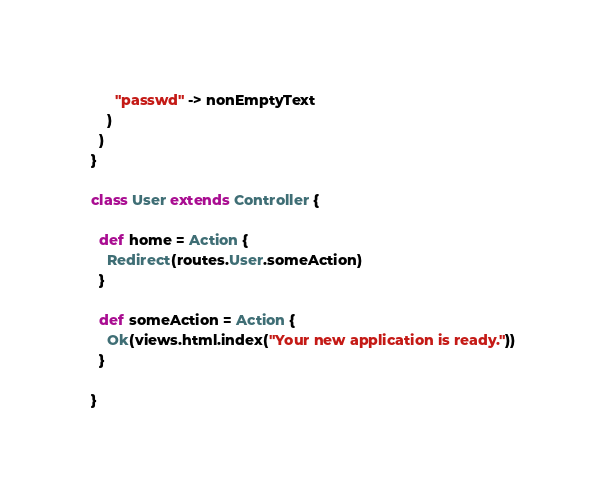Convert code to text. <code><loc_0><loc_0><loc_500><loc_500><_Scala_>      "passwd" -> nonEmptyText
    )
  )
}

class User extends Controller {

  def home = Action {
    Redirect(routes.User.someAction)
  }

  def someAction = Action {
    Ok(views.html.index("Your new application is ready."))
  }

}
</code> 